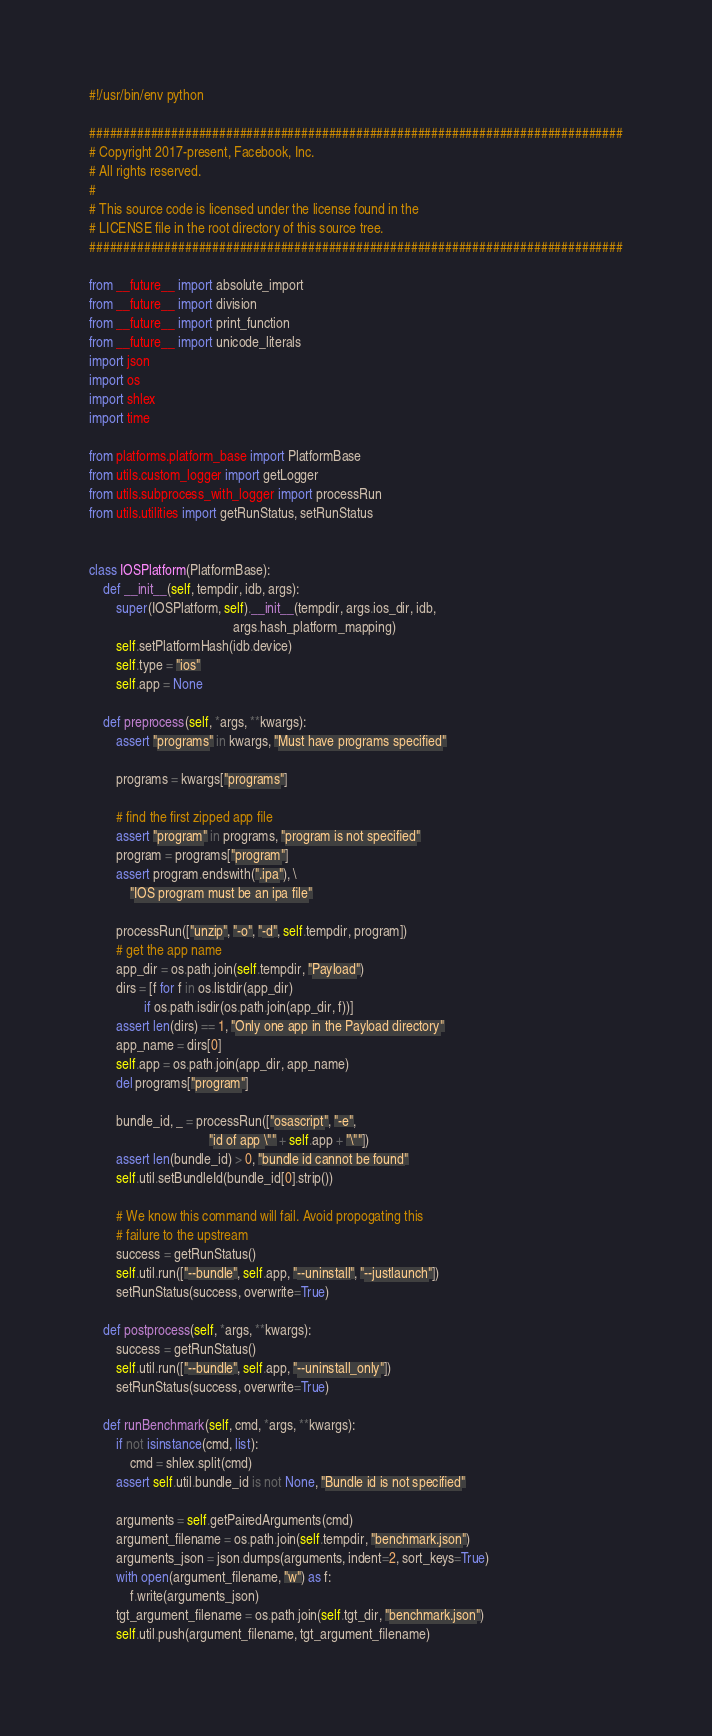Convert code to text. <code><loc_0><loc_0><loc_500><loc_500><_Python_>#!/usr/bin/env python

##############################################################################
# Copyright 2017-present, Facebook, Inc.
# All rights reserved.
#
# This source code is licensed under the license found in the
# LICENSE file in the root directory of this source tree.
##############################################################################

from __future__ import absolute_import
from __future__ import division
from __future__ import print_function
from __future__ import unicode_literals
import json
import os
import shlex
import time

from platforms.platform_base import PlatformBase
from utils.custom_logger import getLogger
from utils.subprocess_with_logger import processRun
from utils.utilities import getRunStatus, setRunStatus


class IOSPlatform(PlatformBase):
    def __init__(self, tempdir, idb, args):
        super(IOSPlatform, self).__init__(tempdir, args.ios_dir, idb,
                                          args.hash_platform_mapping)
        self.setPlatformHash(idb.device)
        self.type = "ios"
        self.app = None

    def preprocess(self, *args, **kwargs):
        assert "programs" in kwargs, "Must have programs specified"

        programs = kwargs["programs"]

        # find the first zipped app file
        assert "program" in programs, "program is not specified"
        program = programs["program"]
        assert program.endswith(".ipa"), \
            "IOS program must be an ipa file"

        processRun(["unzip", "-o", "-d", self.tempdir, program])
        # get the app name
        app_dir = os.path.join(self.tempdir, "Payload")
        dirs = [f for f in os.listdir(app_dir)
                if os.path.isdir(os.path.join(app_dir, f))]
        assert len(dirs) == 1, "Only one app in the Payload directory"
        app_name = dirs[0]
        self.app = os.path.join(app_dir, app_name)
        del programs["program"]

        bundle_id, _ = processRun(["osascript", "-e",
                                   "id of app \"" + self.app + "\""])
        assert len(bundle_id) > 0, "bundle id cannot be found"
        self.util.setBundleId(bundle_id[0].strip())

        # We know this command will fail. Avoid propogating this
        # failure to the upstream
        success = getRunStatus()
        self.util.run(["--bundle", self.app, "--uninstall", "--justlaunch"])
        setRunStatus(success, overwrite=True)

    def postprocess(self, *args, **kwargs):
        success = getRunStatus()
        self.util.run(["--bundle", self.app, "--uninstall_only"])
        setRunStatus(success, overwrite=True)

    def runBenchmark(self, cmd, *args, **kwargs):
        if not isinstance(cmd, list):
            cmd = shlex.split(cmd)
        assert self.util.bundle_id is not None, "Bundle id is not specified"

        arguments = self.getPairedArguments(cmd)
        argument_filename = os.path.join(self.tempdir, "benchmark.json")
        arguments_json = json.dumps(arguments, indent=2, sort_keys=True)
        with open(argument_filename, "w") as f:
            f.write(arguments_json)
        tgt_argument_filename = os.path.join(self.tgt_dir, "benchmark.json")
        self.util.push(argument_filename, tgt_argument_filename)
</code> 